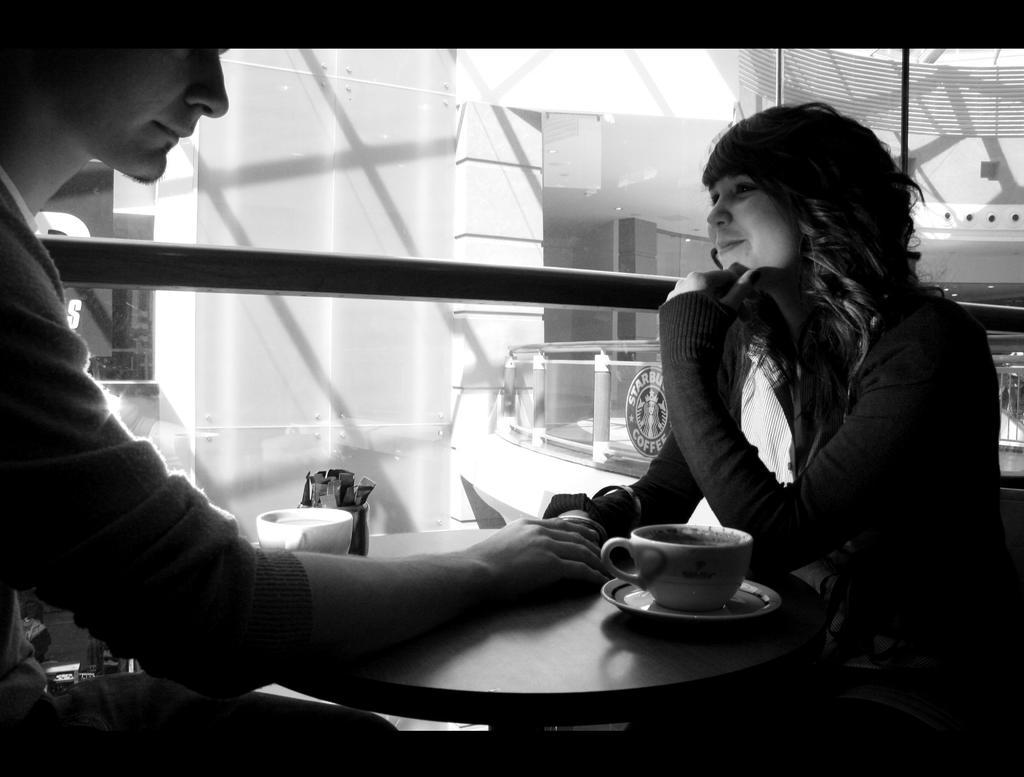Could you give a brief overview of what you see in this image? In this picture there is a man and a woman sitting on the chair. There is a cup, saucer, box on the table. There is a glass and building at the background. 